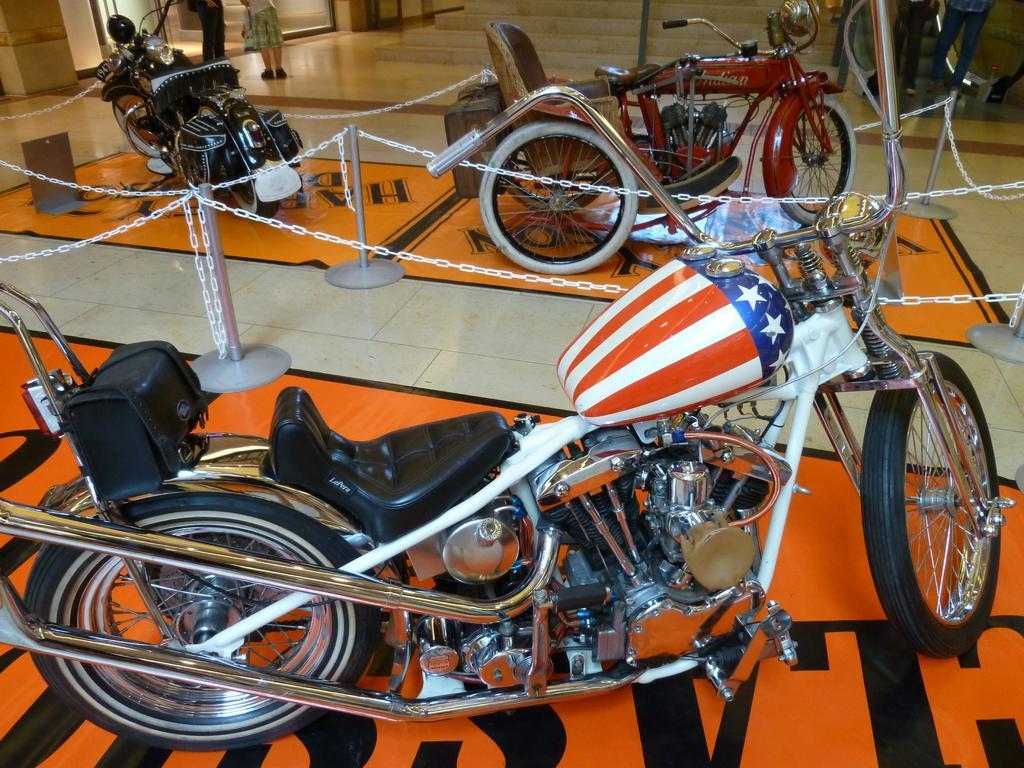Please provide a concise description of this image. There are three different types of motorbikes. These are the iron chains, which are tied to the poles. In the background, I can see two people standing. These are the stairs. On the right side of the image, I can see two people standing near the escalator. 